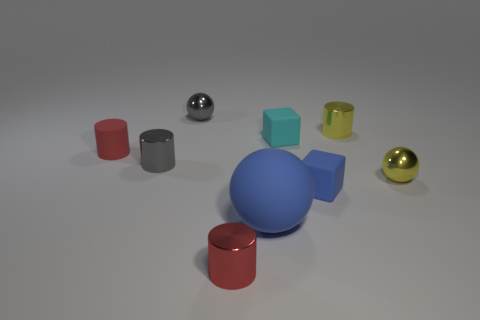Subtract all spheres. How many objects are left? 6 Subtract 1 yellow spheres. How many objects are left? 8 Subtract all tiny cylinders. Subtract all small cyan matte cylinders. How many objects are left? 5 Add 8 tiny yellow cylinders. How many tiny yellow cylinders are left? 9 Add 8 small blue objects. How many small blue objects exist? 9 